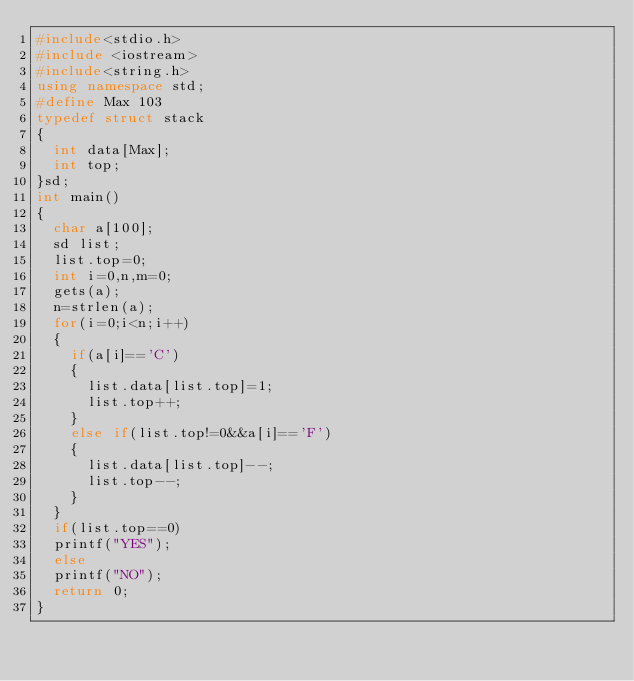Convert code to text. <code><loc_0><loc_0><loc_500><loc_500><_C++_>#include<stdio.h>
#include <iostream>
#include<string.h>
using namespace std;
#define Max 103
typedef struct stack
{
	int data[Max];
	int top;
}sd;              
int main()
{
	char a[100];
	sd list;
	list.top=0;
	int i=0,n,m=0;
	gets(a);
	n=strlen(a);
	for(i=0;i<n;i++)
	{
		if(a[i]=='C')
		{
			list.data[list.top]=1;
			list.top++;
		}
		else if(list.top!=0&&a[i]=='F')
		{
			list.data[list.top]--;
			list.top--;
		}
	}
	if(list.top==0)
	printf("YES");
	else
	printf("NO");
	return 0;
}
</code> 